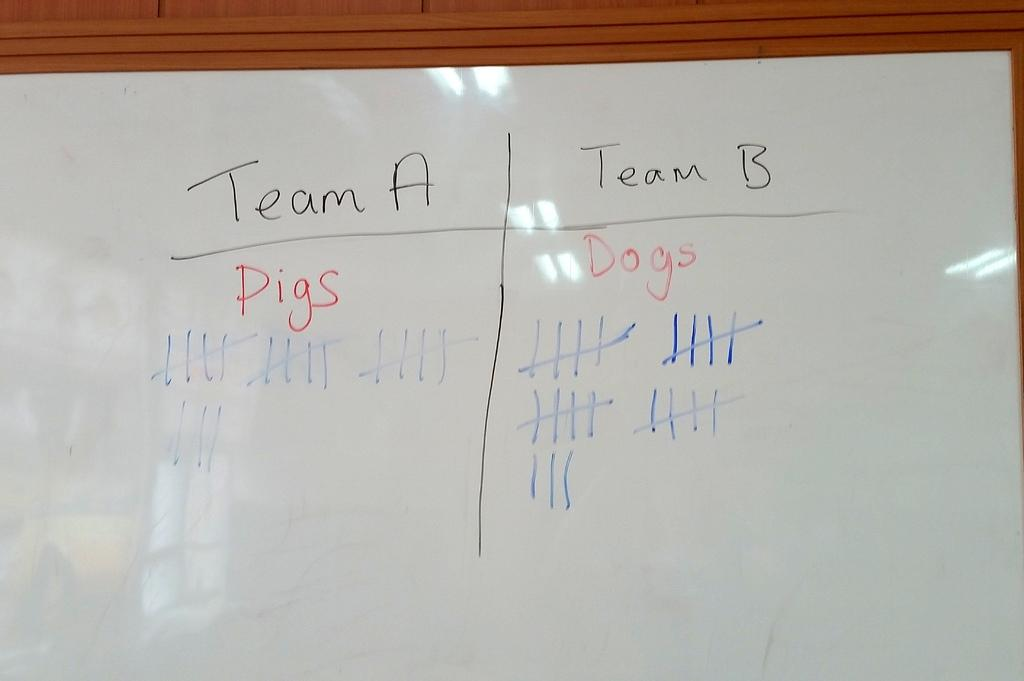<image>
Write a terse but informative summary of the picture. A white board has a column for Team A and Team B with score tallies. 